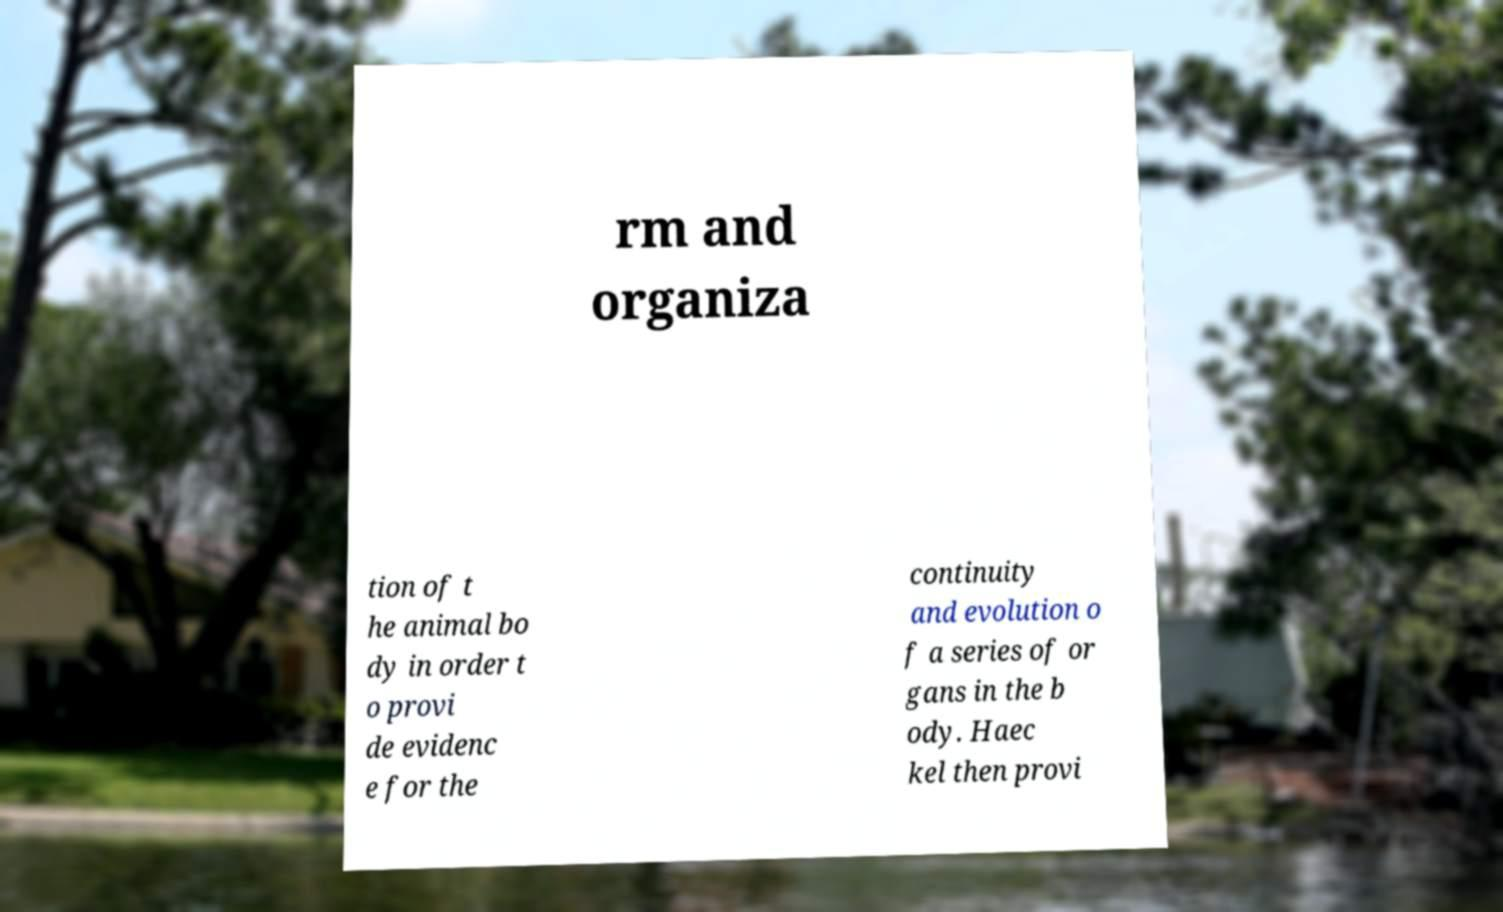For documentation purposes, I need the text within this image transcribed. Could you provide that? rm and organiza tion of t he animal bo dy in order t o provi de evidenc e for the continuity and evolution o f a series of or gans in the b ody. Haec kel then provi 